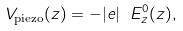<formula> <loc_0><loc_0><loc_500><loc_500>V _ { \text {piezo} } ( z ) = - | e | \ E ^ { 0 } _ { z } ( z ) ,</formula> 